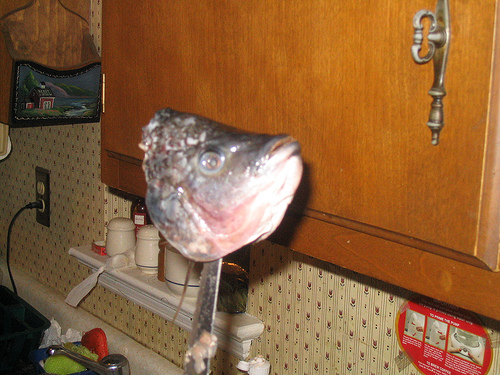<image>
Can you confirm if the wood is to the left of the fish head? Yes. From this viewpoint, the wood is positioned to the left side relative to the fish head. 